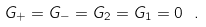<formula> <loc_0><loc_0><loc_500><loc_500>G _ { + } = G _ { - } = G _ { 2 } = G _ { 1 } = 0 \ .</formula> 